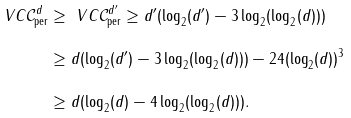<formula> <loc_0><loc_0><loc_500><loc_500>\ V C { \mathcal { C } ^ { d } _ { \text {per} } } & \geq \ V C { \mathcal { C } ^ { d ^ { \prime } } _ { \text {per} } } \geq d ^ { \prime } ( \log _ { 2 } ( d ^ { \prime } ) - 3 \log _ { 2 } ( \log _ { 2 } ( d ) ) ) \\ & \geq d ( \log _ { 2 } ( d ^ { \prime } ) - 3 \log _ { 2 } ( \log _ { 2 } ( d ) ) ) - 2 4 ( \log _ { 2 } ( d ) ) ^ { 3 } \\ & \geq d ( \log _ { 2 } ( d ) - 4 \log _ { 2 } ( \log _ { 2 } ( d ) ) ) .</formula> 